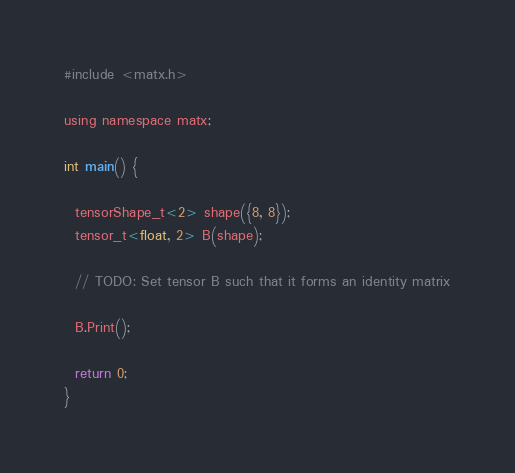Convert code to text. <code><loc_0><loc_0><loc_500><loc_500><_Cuda_>#include <matx.h>

using namespace matx;

int main() {

  tensorShape_t<2> shape({8, 8});
  tensor_t<float, 2> B(shape);

  // TODO: Set tensor B such that it forms an identity matrix

  B.Print();

  return 0;
}
</code> 